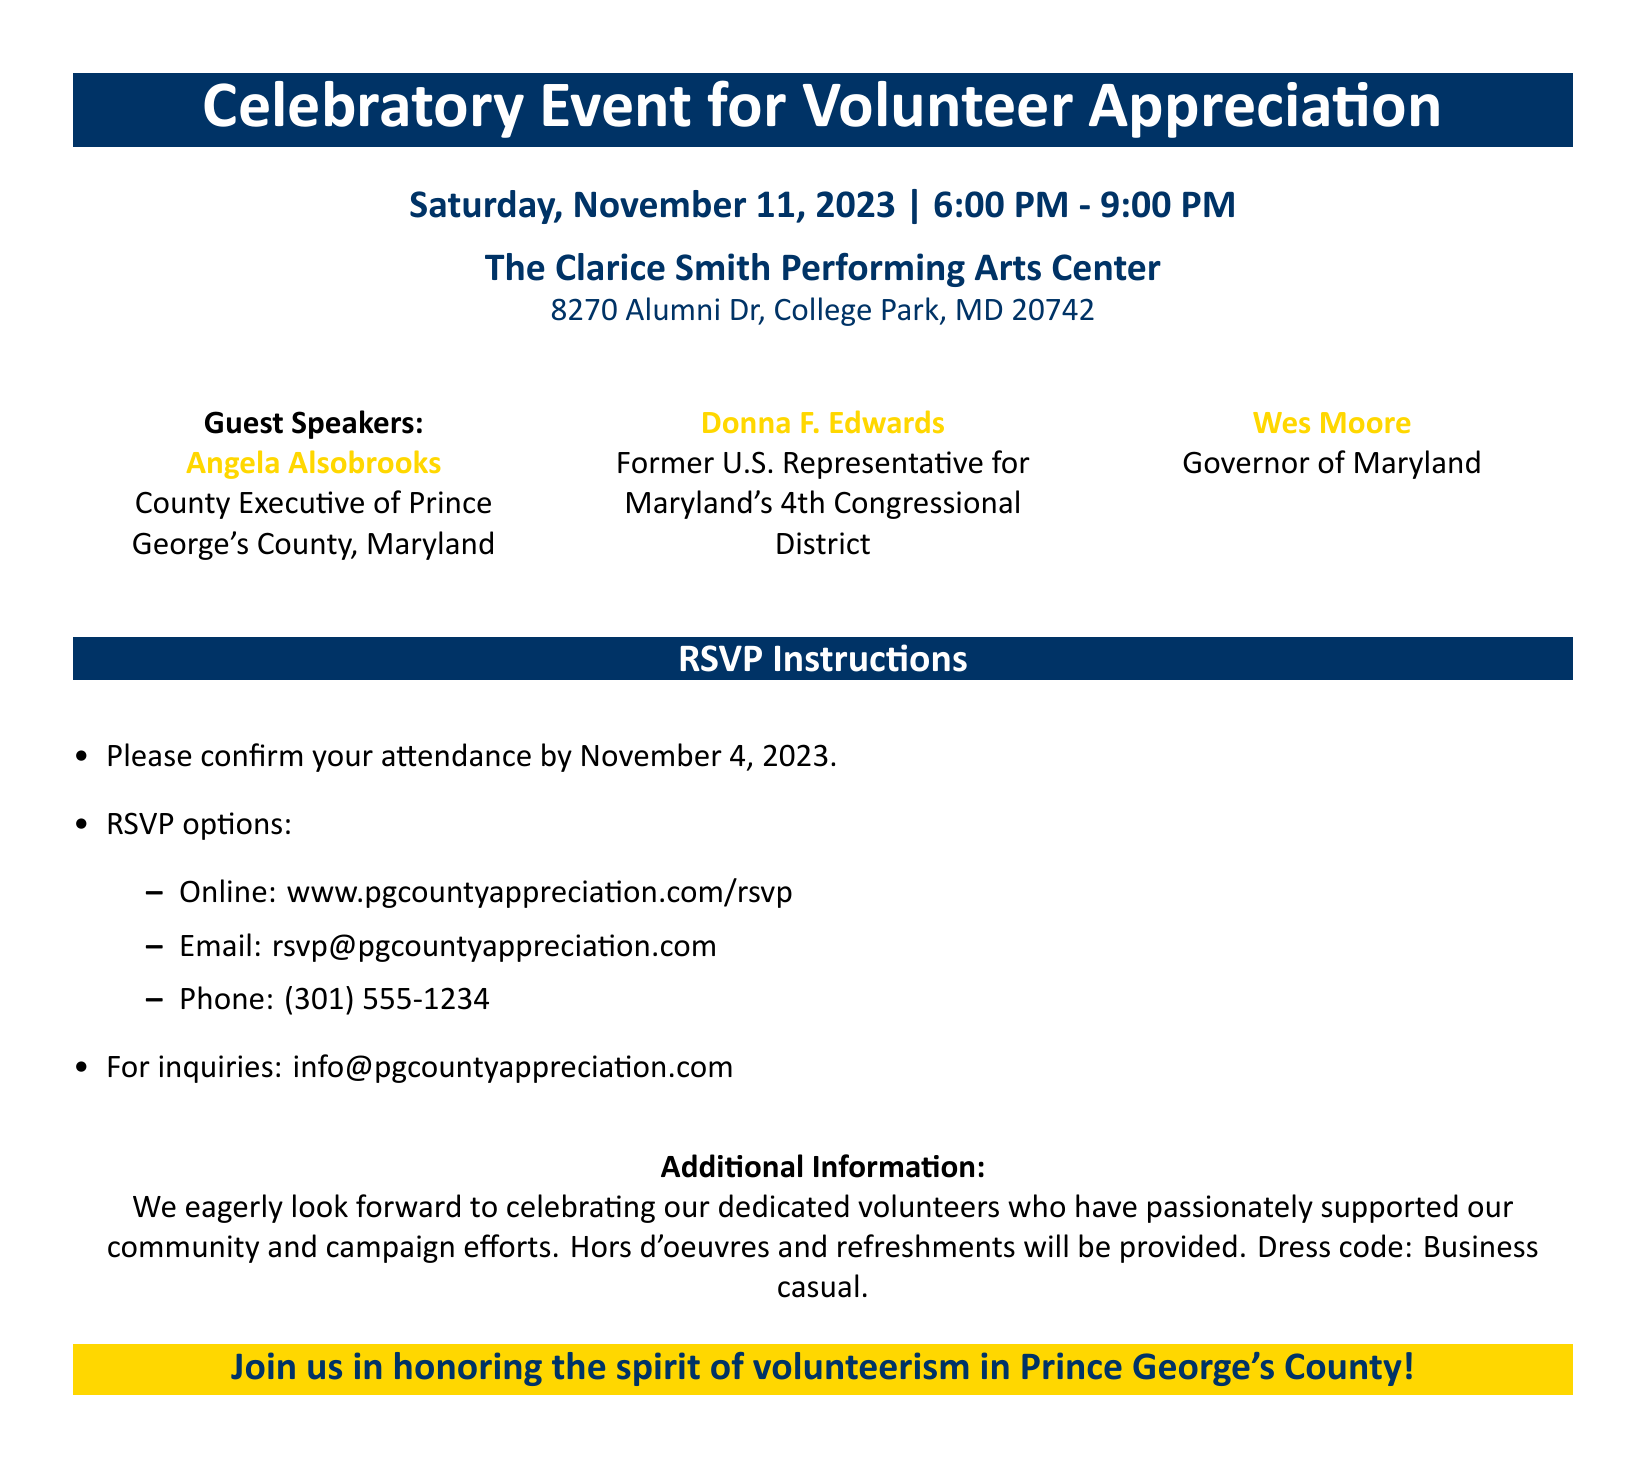What is the date of the event? The event is scheduled for Saturday, November 11, 2023.
Answer: November 11, 2023 What time does the event start? The event starts at 6:00 PM.
Answer: 6:00 PM Who is one of the guest speakers? One of the guest speakers is Angela Alsobrooks.
Answer: Angela Alsobrooks What is the dress code for the event? The dress code specified is business casual.
Answer: Business casual How can you RSVP online? To RSVP online, you can visit the provided website link.
Answer: www.pgcountyappreciation.com/rsvp What is the address of the venue? The address of the venue is 8270 Alumni Dr, College Park, MD 20742.
Answer: 8270 Alumni Dr, College Park, MD 20742 By what date must you confirm attendance? Attendance must be confirmed by November 4, 2023.
Answer: November 4, 2023 What type of food will be provided at the event? The document states that hors d'oeuvres and refreshments will be provided.
Answer: Hors d'oeuvres and refreshments Which guest speaker is the Governor of Maryland? The Governor of Maryland is Wes Moore.
Answer: Wes Moore 